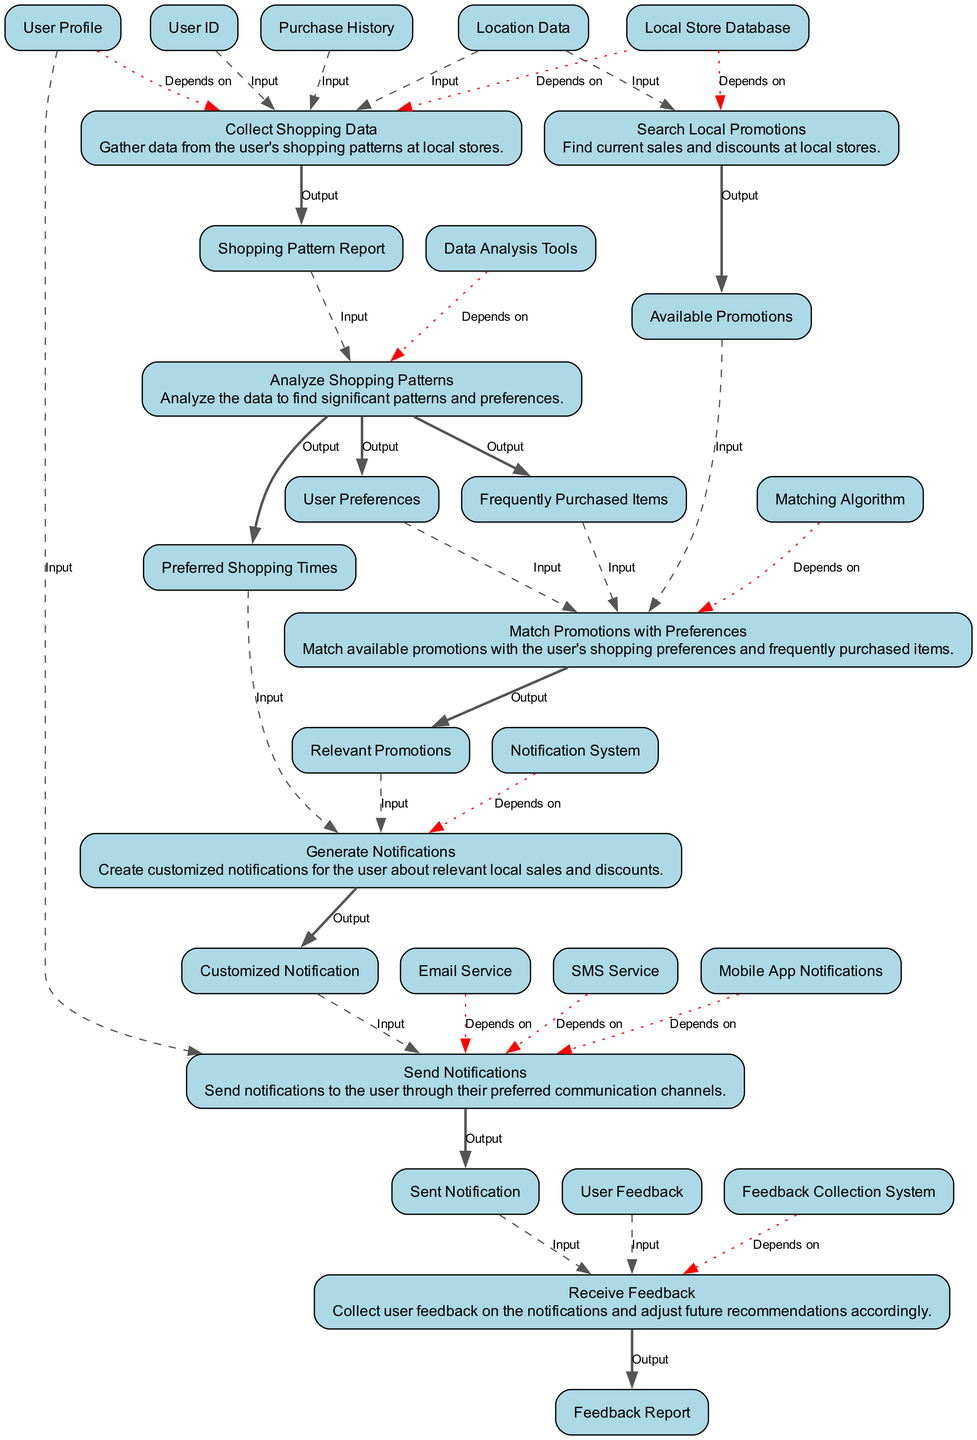What is the first step in the diagram? The first step, as indicated in the diagram, is "Collect Shopping Data," which gathers user-specific shopping patterns from local stores.
Answer: Collect Shopping Data How many inputs does the "Analyze Shopping Patterns" step require? The "Analyze Shopping Patterns" node has one input, which is the "Shopping Pattern Report" generated from a previous step.
Answer: 1 What outputs does the "Search Local Promotions" produce? The "Search Local Promotions" step produces one output, which is "Available Promotions" that lists current sales and discounts at local stores.
Answer: Available Promotions Which step depends on the "Data Analysis Tools"? The step "Analyze Shopping Patterns" relies on "Data Analysis Tools" as its dependency for processing the shopping pattern report.
Answer: Analyze Shopping Patterns How many edges are associated with the "Send Notifications" step? The "Send Notifications" step has three edges: one input edge from "Customized Notification," one input edge from "User Profile," and one output edge labeled "Sent Notification."
Answer: 3 What is the final output of the "Generate Notifications" step? The output from the "Generate Notifications" step is "Customized Notification," which is tailored messaging for the user regarding relevant promotions.
Answer: Customized Notification Which two elements are directly linked by a bold edge? The elements "Match Promotions with Preferences" and "Relevant Promotions" are linked by a bold edge, indicating that the former produces the latter.
Answer: Match Promotions with Preferences and Relevant Promotions What happens after "Receive Feedback" is completed? After "Receive Feedback" is completed, a "Feedback Report" is generated which can inform future recommendations to the user based on their input.
Answer: Feedback Report 